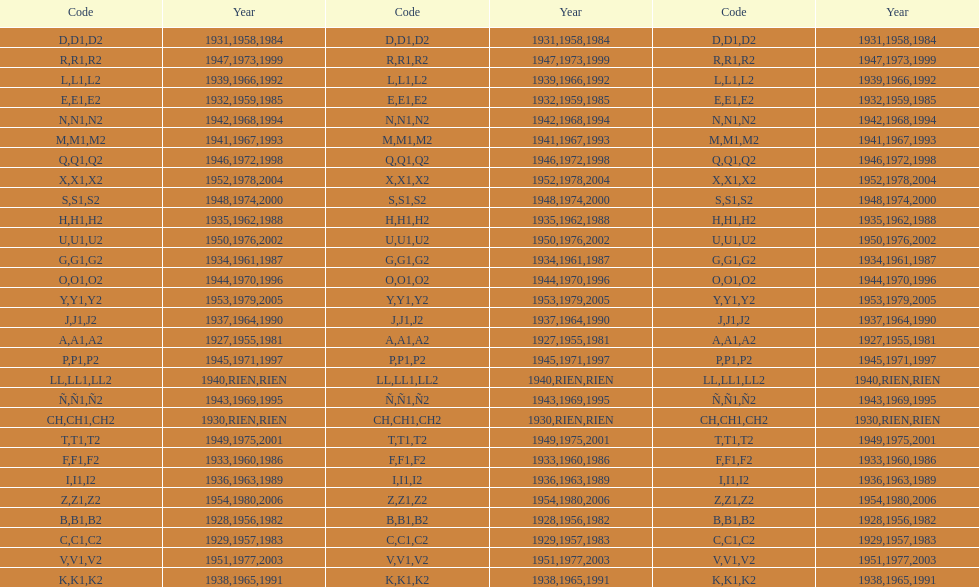List each code not associated to a year. CH1, CH2, LL1, LL2. 